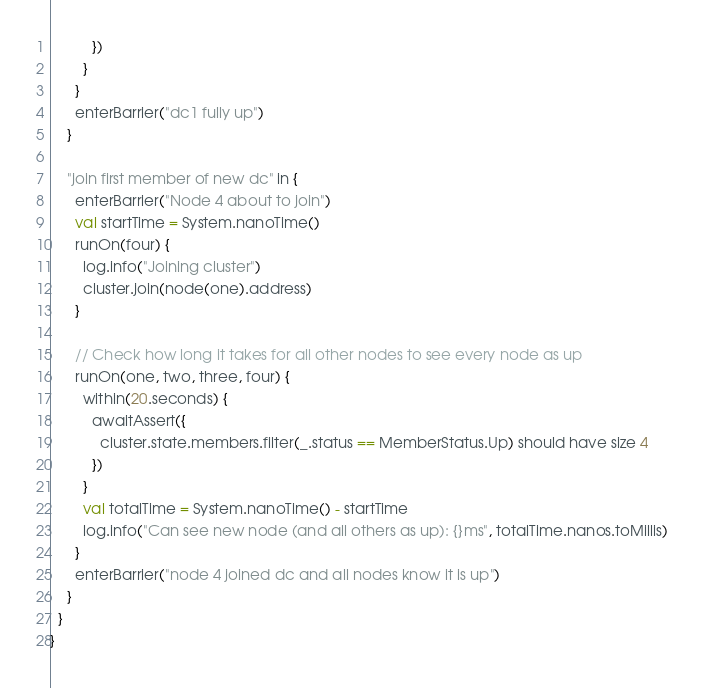<code> <loc_0><loc_0><loc_500><loc_500><_Scala_>          })
        }
      }
      enterBarrier("dc1 fully up")
    }

    "join first member of new dc" in {
      enterBarrier("Node 4 about to join")
      val startTime = System.nanoTime()
      runOn(four) {
        log.info("Joining cluster")
        cluster.join(node(one).address)
      }

      // Check how long it takes for all other nodes to see every node as up
      runOn(one, two, three, four) {
        within(20.seconds) {
          awaitAssert({
            cluster.state.members.filter(_.status == MemberStatus.Up) should have size 4
          })
        }
        val totalTime = System.nanoTime() - startTime
        log.info("Can see new node (and all others as up): {}ms", totalTime.nanos.toMillis)
      }
      enterBarrier("node 4 joined dc and all nodes know it is up")
    }
  }
}
</code> 